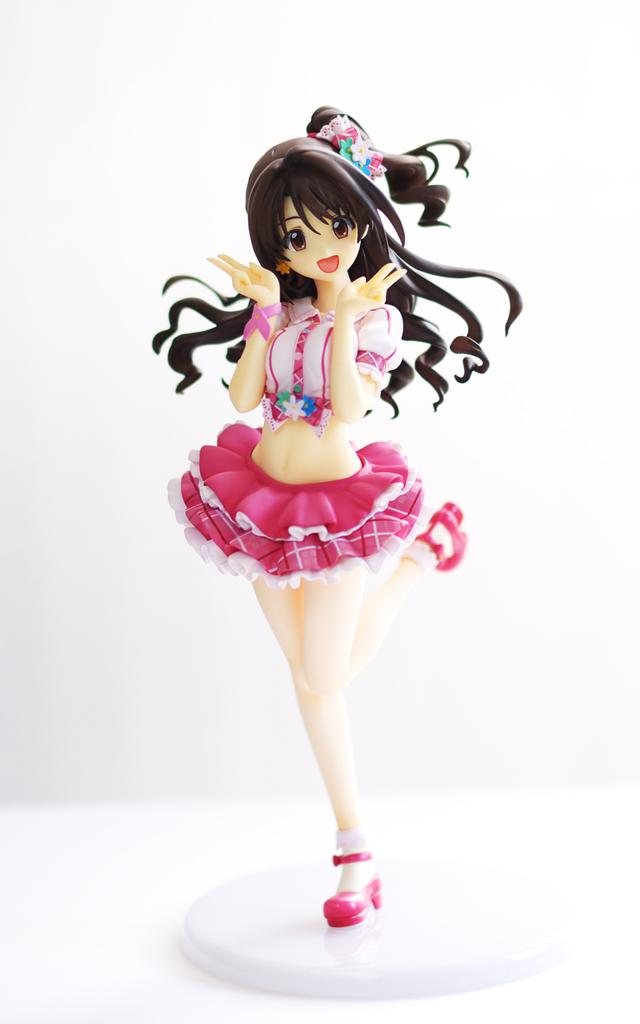What is the main subject of the image? There is a doll in the image. What color is the background of the image? The background of the image is white. What type of vegetable is being advertised in the image? There is no vegetable being advertised in the image; it features a doll with a white background. What industry is depicted in the image? There is no specific industry depicted in the image; it only shows a doll and features a doll with a white background. 